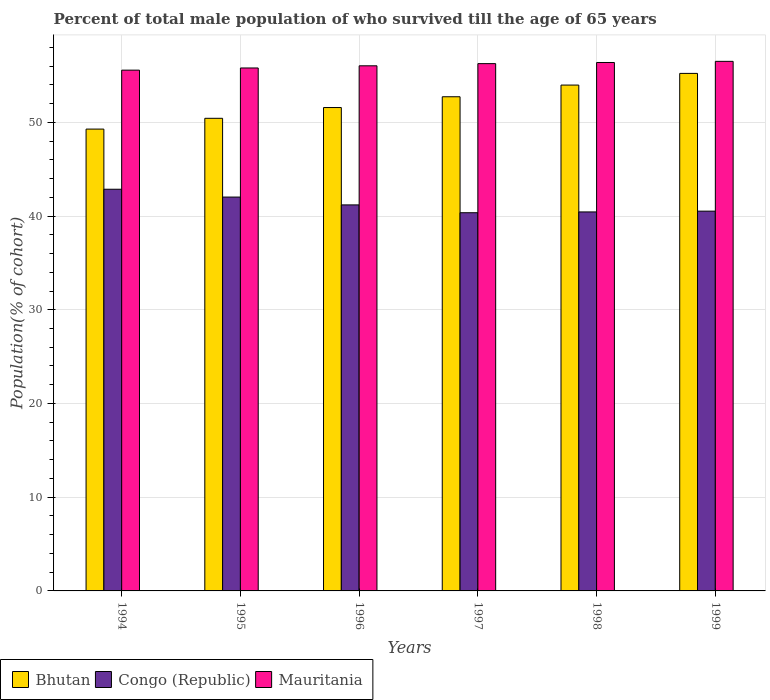How many different coloured bars are there?
Your answer should be very brief. 3. How many groups of bars are there?
Provide a succinct answer. 6. Are the number of bars per tick equal to the number of legend labels?
Provide a short and direct response. Yes. Are the number of bars on each tick of the X-axis equal?
Make the answer very short. Yes. What is the percentage of total male population who survived till the age of 65 years in Congo (Republic) in 1997?
Your response must be concise. 40.35. Across all years, what is the maximum percentage of total male population who survived till the age of 65 years in Bhutan?
Offer a very short reply. 55.22. Across all years, what is the minimum percentage of total male population who survived till the age of 65 years in Mauritania?
Your answer should be compact. 55.57. What is the total percentage of total male population who survived till the age of 65 years in Bhutan in the graph?
Make the answer very short. 313.19. What is the difference between the percentage of total male population who survived till the age of 65 years in Mauritania in 1996 and that in 1998?
Give a very brief answer. -0.35. What is the difference between the percentage of total male population who survived till the age of 65 years in Congo (Republic) in 1996 and the percentage of total male population who survived till the age of 65 years in Mauritania in 1995?
Offer a terse response. -14.61. What is the average percentage of total male population who survived till the age of 65 years in Congo (Republic) per year?
Offer a terse response. 41.23. In the year 1998, what is the difference between the percentage of total male population who survived till the age of 65 years in Mauritania and percentage of total male population who survived till the age of 65 years in Congo (Republic)?
Your response must be concise. 15.94. What is the ratio of the percentage of total male population who survived till the age of 65 years in Bhutan in 1996 to that in 1998?
Your answer should be compact. 0.96. What is the difference between the highest and the second highest percentage of total male population who survived till the age of 65 years in Bhutan?
Give a very brief answer. 1.25. What is the difference between the highest and the lowest percentage of total male population who survived till the age of 65 years in Bhutan?
Your response must be concise. 5.94. In how many years, is the percentage of total male population who survived till the age of 65 years in Bhutan greater than the average percentage of total male population who survived till the age of 65 years in Bhutan taken over all years?
Give a very brief answer. 3. Is the sum of the percentage of total male population who survived till the age of 65 years in Congo (Republic) in 1994 and 1997 greater than the maximum percentage of total male population who survived till the age of 65 years in Bhutan across all years?
Your answer should be very brief. Yes. What does the 2nd bar from the left in 1996 represents?
Make the answer very short. Congo (Republic). What does the 3rd bar from the right in 1995 represents?
Keep it short and to the point. Bhutan. What is the difference between two consecutive major ticks on the Y-axis?
Make the answer very short. 10. Does the graph contain any zero values?
Offer a terse response. No. How many legend labels are there?
Make the answer very short. 3. What is the title of the graph?
Your answer should be very brief. Percent of total male population of who survived till the age of 65 years. What is the label or title of the Y-axis?
Your answer should be very brief. Population(% of cohort). What is the Population(% of cohort) of Bhutan in 1994?
Offer a very short reply. 49.28. What is the Population(% of cohort) of Congo (Republic) in 1994?
Your answer should be compact. 42.86. What is the Population(% of cohort) of Mauritania in 1994?
Give a very brief answer. 55.57. What is the Population(% of cohort) of Bhutan in 1995?
Offer a terse response. 50.43. What is the Population(% of cohort) of Congo (Republic) in 1995?
Your answer should be very brief. 42.02. What is the Population(% of cohort) in Mauritania in 1995?
Provide a short and direct response. 55.8. What is the Population(% of cohort) of Bhutan in 1996?
Offer a very short reply. 51.58. What is the Population(% of cohort) of Congo (Republic) in 1996?
Offer a very short reply. 41.19. What is the Population(% of cohort) of Mauritania in 1996?
Offer a very short reply. 56.03. What is the Population(% of cohort) in Bhutan in 1997?
Offer a terse response. 52.73. What is the Population(% of cohort) in Congo (Republic) in 1997?
Your response must be concise. 40.35. What is the Population(% of cohort) of Mauritania in 1997?
Provide a short and direct response. 56.26. What is the Population(% of cohort) in Bhutan in 1998?
Offer a terse response. 53.97. What is the Population(% of cohort) of Congo (Republic) in 1998?
Offer a very short reply. 40.44. What is the Population(% of cohort) of Mauritania in 1998?
Your response must be concise. 56.38. What is the Population(% of cohort) in Bhutan in 1999?
Your answer should be compact. 55.22. What is the Population(% of cohort) in Congo (Republic) in 1999?
Ensure brevity in your answer.  40.52. What is the Population(% of cohort) of Mauritania in 1999?
Offer a very short reply. 56.5. Across all years, what is the maximum Population(% of cohort) of Bhutan?
Your answer should be very brief. 55.22. Across all years, what is the maximum Population(% of cohort) in Congo (Republic)?
Ensure brevity in your answer.  42.86. Across all years, what is the maximum Population(% of cohort) in Mauritania?
Provide a short and direct response. 56.5. Across all years, what is the minimum Population(% of cohort) of Bhutan?
Offer a very short reply. 49.28. Across all years, what is the minimum Population(% of cohort) in Congo (Republic)?
Keep it short and to the point. 40.35. Across all years, what is the minimum Population(% of cohort) of Mauritania?
Provide a short and direct response. 55.57. What is the total Population(% of cohort) of Bhutan in the graph?
Offer a terse response. 313.19. What is the total Population(% of cohort) of Congo (Republic) in the graph?
Make the answer very short. 247.38. What is the total Population(% of cohort) in Mauritania in the graph?
Your answer should be very brief. 336.53. What is the difference between the Population(% of cohort) in Bhutan in 1994 and that in 1995?
Your answer should be very brief. -1.15. What is the difference between the Population(% of cohort) in Congo (Republic) in 1994 and that in 1995?
Your answer should be compact. 0.84. What is the difference between the Population(% of cohort) in Mauritania in 1994 and that in 1995?
Keep it short and to the point. -0.23. What is the difference between the Population(% of cohort) in Bhutan in 1994 and that in 1996?
Make the answer very short. -2.3. What is the difference between the Population(% of cohort) of Congo (Republic) in 1994 and that in 1996?
Your response must be concise. 1.67. What is the difference between the Population(% of cohort) of Mauritania in 1994 and that in 1996?
Offer a terse response. -0.46. What is the difference between the Population(% of cohort) of Bhutan in 1994 and that in 1997?
Offer a very short reply. -3.45. What is the difference between the Population(% of cohort) in Congo (Republic) in 1994 and that in 1997?
Offer a very short reply. 2.51. What is the difference between the Population(% of cohort) of Mauritania in 1994 and that in 1997?
Your response must be concise. -0.69. What is the difference between the Population(% of cohort) of Bhutan in 1994 and that in 1998?
Give a very brief answer. -4.7. What is the difference between the Population(% of cohort) in Congo (Republic) in 1994 and that in 1998?
Provide a short and direct response. 2.42. What is the difference between the Population(% of cohort) of Mauritania in 1994 and that in 1998?
Provide a short and direct response. -0.82. What is the difference between the Population(% of cohort) of Bhutan in 1994 and that in 1999?
Provide a succinct answer. -5.94. What is the difference between the Population(% of cohort) of Congo (Republic) in 1994 and that in 1999?
Your answer should be very brief. 2.34. What is the difference between the Population(% of cohort) in Mauritania in 1994 and that in 1999?
Your answer should be compact. -0.94. What is the difference between the Population(% of cohort) in Bhutan in 1995 and that in 1996?
Provide a succinct answer. -1.15. What is the difference between the Population(% of cohort) of Congo (Republic) in 1995 and that in 1996?
Give a very brief answer. 0.84. What is the difference between the Population(% of cohort) of Mauritania in 1995 and that in 1996?
Give a very brief answer. -0.23. What is the difference between the Population(% of cohort) in Bhutan in 1995 and that in 1997?
Your answer should be very brief. -2.3. What is the difference between the Population(% of cohort) of Congo (Republic) in 1995 and that in 1997?
Your answer should be compact. 1.67. What is the difference between the Population(% of cohort) of Mauritania in 1995 and that in 1997?
Offer a very short reply. -0.46. What is the difference between the Population(% of cohort) of Bhutan in 1995 and that in 1998?
Offer a terse response. -3.55. What is the difference between the Population(% of cohort) of Congo (Republic) in 1995 and that in 1998?
Give a very brief answer. 1.59. What is the difference between the Population(% of cohort) in Mauritania in 1995 and that in 1998?
Provide a short and direct response. -0.58. What is the difference between the Population(% of cohort) in Bhutan in 1995 and that in 1999?
Provide a short and direct response. -4.79. What is the difference between the Population(% of cohort) of Congo (Republic) in 1995 and that in 1999?
Give a very brief answer. 1.5. What is the difference between the Population(% of cohort) of Mauritania in 1995 and that in 1999?
Provide a short and direct response. -0.71. What is the difference between the Population(% of cohort) in Bhutan in 1996 and that in 1997?
Provide a short and direct response. -1.15. What is the difference between the Population(% of cohort) of Congo (Republic) in 1996 and that in 1997?
Your answer should be compact. 0.84. What is the difference between the Population(% of cohort) in Mauritania in 1996 and that in 1997?
Provide a succinct answer. -0.23. What is the difference between the Population(% of cohort) of Bhutan in 1996 and that in 1998?
Keep it short and to the point. -2.4. What is the difference between the Population(% of cohort) in Congo (Republic) in 1996 and that in 1998?
Make the answer very short. 0.75. What is the difference between the Population(% of cohort) in Mauritania in 1996 and that in 1998?
Ensure brevity in your answer.  -0.35. What is the difference between the Population(% of cohort) of Bhutan in 1996 and that in 1999?
Offer a very short reply. -3.64. What is the difference between the Population(% of cohort) in Congo (Republic) in 1996 and that in 1999?
Ensure brevity in your answer.  0.67. What is the difference between the Population(% of cohort) in Mauritania in 1996 and that in 1999?
Your response must be concise. -0.47. What is the difference between the Population(% of cohort) in Bhutan in 1997 and that in 1998?
Your answer should be compact. -1.25. What is the difference between the Population(% of cohort) in Congo (Republic) in 1997 and that in 1998?
Keep it short and to the point. -0.08. What is the difference between the Population(% of cohort) of Mauritania in 1997 and that in 1998?
Offer a very short reply. -0.12. What is the difference between the Population(% of cohort) of Bhutan in 1997 and that in 1999?
Your answer should be very brief. -2.49. What is the difference between the Population(% of cohort) in Congo (Republic) in 1997 and that in 1999?
Make the answer very short. -0.17. What is the difference between the Population(% of cohort) of Mauritania in 1997 and that in 1999?
Offer a very short reply. -0.24. What is the difference between the Population(% of cohort) of Bhutan in 1998 and that in 1999?
Your response must be concise. -1.25. What is the difference between the Population(% of cohort) in Congo (Republic) in 1998 and that in 1999?
Offer a very short reply. -0.08. What is the difference between the Population(% of cohort) of Mauritania in 1998 and that in 1999?
Offer a very short reply. -0.12. What is the difference between the Population(% of cohort) in Bhutan in 1994 and the Population(% of cohort) in Congo (Republic) in 1995?
Provide a succinct answer. 7.25. What is the difference between the Population(% of cohort) of Bhutan in 1994 and the Population(% of cohort) of Mauritania in 1995?
Ensure brevity in your answer.  -6.52. What is the difference between the Population(% of cohort) in Congo (Republic) in 1994 and the Population(% of cohort) in Mauritania in 1995?
Keep it short and to the point. -12.94. What is the difference between the Population(% of cohort) of Bhutan in 1994 and the Population(% of cohort) of Congo (Republic) in 1996?
Keep it short and to the point. 8.09. What is the difference between the Population(% of cohort) in Bhutan in 1994 and the Population(% of cohort) in Mauritania in 1996?
Provide a short and direct response. -6.75. What is the difference between the Population(% of cohort) of Congo (Republic) in 1994 and the Population(% of cohort) of Mauritania in 1996?
Your answer should be very brief. -13.17. What is the difference between the Population(% of cohort) of Bhutan in 1994 and the Population(% of cohort) of Congo (Republic) in 1997?
Provide a succinct answer. 8.92. What is the difference between the Population(% of cohort) in Bhutan in 1994 and the Population(% of cohort) in Mauritania in 1997?
Offer a terse response. -6.98. What is the difference between the Population(% of cohort) of Congo (Republic) in 1994 and the Population(% of cohort) of Mauritania in 1997?
Make the answer very short. -13.4. What is the difference between the Population(% of cohort) of Bhutan in 1994 and the Population(% of cohort) of Congo (Republic) in 1998?
Ensure brevity in your answer.  8.84. What is the difference between the Population(% of cohort) of Bhutan in 1994 and the Population(% of cohort) of Mauritania in 1998?
Make the answer very short. -7.1. What is the difference between the Population(% of cohort) in Congo (Republic) in 1994 and the Population(% of cohort) in Mauritania in 1998?
Your answer should be very brief. -13.52. What is the difference between the Population(% of cohort) in Bhutan in 1994 and the Population(% of cohort) in Congo (Republic) in 1999?
Your answer should be compact. 8.76. What is the difference between the Population(% of cohort) in Bhutan in 1994 and the Population(% of cohort) in Mauritania in 1999?
Your answer should be very brief. -7.23. What is the difference between the Population(% of cohort) of Congo (Republic) in 1994 and the Population(% of cohort) of Mauritania in 1999?
Your response must be concise. -13.65. What is the difference between the Population(% of cohort) in Bhutan in 1995 and the Population(% of cohort) in Congo (Republic) in 1996?
Offer a very short reply. 9.24. What is the difference between the Population(% of cohort) of Bhutan in 1995 and the Population(% of cohort) of Mauritania in 1996?
Give a very brief answer. -5.6. What is the difference between the Population(% of cohort) in Congo (Republic) in 1995 and the Population(% of cohort) in Mauritania in 1996?
Provide a succinct answer. -14.01. What is the difference between the Population(% of cohort) of Bhutan in 1995 and the Population(% of cohort) of Congo (Republic) in 1997?
Offer a very short reply. 10.07. What is the difference between the Population(% of cohort) in Bhutan in 1995 and the Population(% of cohort) in Mauritania in 1997?
Ensure brevity in your answer.  -5.83. What is the difference between the Population(% of cohort) of Congo (Republic) in 1995 and the Population(% of cohort) of Mauritania in 1997?
Ensure brevity in your answer.  -14.24. What is the difference between the Population(% of cohort) of Bhutan in 1995 and the Population(% of cohort) of Congo (Republic) in 1998?
Provide a short and direct response. 9.99. What is the difference between the Population(% of cohort) of Bhutan in 1995 and the Population(% of cohort) of Mauritania in 1998?
Offer a terse response. -5.96. What is the difference between the Population(% of cohort) in Congo (Republic) in 1995 and the Population(% of cohort) in Mauritania in 1998?
Your answer should be compact. -14.36. What is the difference between the Population(% of cohort) in Bhutan in 1995 and the Population(% of cohort) in Congo (Republic) in 1999?
Provide a short and direct response. 9.9. What is the difference between the Population(% of cohort) of Bhutan in 1995 and the Population(% of cohort) of Mauritania in 1999?
Your answer should be very brief. -6.08. What is the difference between the Population(% of cohort) of Congo (Republic) in 1995 and the Population(% of cohort) of Mauritania in 1999?
Your answer should be compact. -14.48. What is the difference between the Population(% of cohort) of Bhutan in 1996 and the Population(% of cohort) of Congo (Republic) in 1997?
Offer a very short reply. 11.22. What is the difference between the Population(% of cohort) in Bhutan in 1996 and the Population(% of cohort) in Mauritania in 1997?
Offer a terse response. -4.68. What is the difference between the Population(% of cohort) of Congo (Republic) in 1996 and the Population(% of cohort) of Mauritania in 1997?
Offer a terse response. -15.07. What is the difference between the Population(% of cohort) of Bhutan in 1996 and the Population(% of cohort) of Congo (Republic) in 1998?
Provide a short and direct response. 11.14. What is the difference between the Population(% of cohort) of Bhutan in 1996 and the Population(% of cohort) of Mauritania in 1998?
Give a very brief answer. -4.81. What is the difference between the Population(% of cohort) of Congo (Republic) in 1996 and the Population(% of cohort) of Mauritania in 1998?
Ensure brevity in your answer.  -15.19. What is the difference between the Population(% of cohort) of Bhutan in 1996 and the Population(% of cohort) of Congo (Republic) in 1999?
Keep it short and to the point. 11.05. What is the difference between the Population(% of cohort) in Bhutan in 1996 and the Population(% of cohort) in Mauritania in 1999?
Provide a succinct answer. -4.93. What is the difference between the Population(% of cohort) in Congo (Republic) in 1996 and the Population(% of cohort) in Mauritania in 1999?
Ensure brevity in your answer.  -15.32. What is the difference between the Population(% of cohort) of Bhutan in 1997 and the Population(% of cohort) of Congo (Republic) in 1998?
Offer a terse response. 12.29. What is the difference between the Population(% of cohort) of Bhutan in 1997 and the Population(% of cohort) of Mauritania in 1998?
Offer a terse response. -3.66. What is the difference between the Population(% of cohort) of Congo (Republic) in 1997 and the Population(% of cohort) of Mauritania in 1998?
Give a very brief answer. -16.03. What is the difference between the Population(% of cohort) in Bhutan in 1997 and the Population(% of cohort) in Congo (Republic) in 1999?
Give a very brief answer. 12.2. What is the difference between the Population(% of cohort) of Bhutan in 1997 and the Population(% of cohort) of Mauritania in 1999?
Offer a very short reply. -3.78. What is the difference between the Population(% of cohort) in Congo (Republic) in 1997 and the Population(% of cohort) in Mauritania in 1999?
Offer a terse response. -16.15. What is the difference between the Population(% of cohort) in Bhutan in 1998 and the Population(% of cohort) in Congo (Republic) in 1999?
Your answer should be compact. 13.45. What is the difference between the Population(% of cohort) in Bhutan in 1998 and the Population(% of cohort) in Mauritania in 1999?
Ensure brevity in your answer.  -2.53. What is the difference between the Population(% of cohort) of Congo (Republic) in 1998 and the Population(% of cohort) of Mauritania in 1999?
Keep it short and to the point. -16.07. What is the average Population(% of cohort) in Bhutan per year?
Your answer should be compact. 52.2. What is the average Population(% of cohort) of Congo (Republic) per year?
Your answer should be compact. 41.23. What is the average Population(% of cohort) of Mauritania per year?
Provide a short and direct response. 56.09. In the year 1994, what is the difference between the Population(% of cohort) in Bhutan and Population(% of cohort) in Congo (Republic)?
Keep it short and to the point. 6.42. In the year 1994, what is the difference between the Population(% of cohort) in Bhutan and Population(% of cohort) in Mauritania?
Make the answer very short. -6.29. In the year 1994, what is the difference between the Population(% of cohort) of Congo (Republic) and Population(% of cohort) of Mauritania?
Offer a terse response. -12.71. In the year 1995, what is the difference between the Population(% of cohort) in Bhutan and Population(% of cohort) in Congo (Republic)?
Offer a terse response. 8.4. In the year 1995, what is the difference between the Population(% of cohort) in Bhutan and Population(% of cohort) in Mauritania?
Provide a short and direct response. -5.37. In the year 1995, what is the difference between the Population(% of cohort) of Congo (Republic) and Population(% of cohort) of Mauritania?
Provide a succinct answer. -13.77. In the year 1996, what is the difference between the Population(% of cohort) in Bhutan and Population(% of cohort) in Congo (Republic)?
Provide a short and direct response. 10.39. In the year 1996, what is the difference between the Population(% of cohort) in Bhutan and Population(% of cohort) in Mauritania?
Make the answer very short. -4.45. In the year 1996, what is the difference between the Population(% of cohort) in Congo (Republic) and Population(% of cohort) in Mauritania?
Offer a very short reply. -14.84. In the year 1997, what is the difference between the Population(% of cohort) in Bhutan and Population(% of cohort) in Congo (Republic)?
Provide a short and direct response. 12.37. In the year 1997, what is the difference between the Population(% of cohort) of Bhutan and Population(% of cohort) of Mauritania?
Your response must be concise. -3.53. In the year 1997, what is the difference between the Population(% of cohort) of Congo (Republic) and Population(% of cohort) of Mauritania?
Keep it short and to the point. -15.91. In the year 1998, what is the difference between the Population(% of cohort) in Bhutan and Population(% of cohort) in Congo (Republic)?
Your answer should be very brief. 13.54. In the year 1998, what is the difference between the Population(% of cohort) of Bhutan and Population(% of cohort) of Mauritania?
Offer a terse response. -2.41. In the year 1998, what is the difference between the Population(% of cohort) of Congo (Republic) and Population(% of cohort) of Mauritania?
Give a very brief answer. -15.94. In the year 1999, what is the difference between the Population(% of cohort) of Bhutan and Population(% of cohort) of Congo (Republic)?
Your answer should be compact. 14.7. In the year 1999, what is the difference between the Population(% of cohort) of Bhutan and Population(% of cohort) of Mauritania?
Your answer should be very brief. -1.28. In the year 1999, what is the difference between the Population(% of cohort) of Congo (Republic) and Population(% of cohort) of Mauritania?
Offer a very short reply. -15.98. What is the ratio of the Population(% of cohort) of Bhutan in 1994 to that in 1995?
Provide a short and direct response. 0.98. What is the ratio of the Population(% of cohort) in Congo (Republic) in 1994 to that in 1995?
Ensure brevity in your answer.  1.02. What is the ratio of the Population(% of cohort) of Mauritania in 1994 to that in 1995?
Give a very brief answer. 1. What is the ratio of the Population(% of cohort) in Bhutan in 1994 to that in 1996?
Offer a terse response. 0.96. What is the ratio of the Population(% of cohort) in Congo (Republic) in 1994 to that in 1996?
Your answer should be very brief. 1.04. What is the ratio of the Population(% of cohort) of Bhutan in 1994 to that in 1997?
Ensure brevity in your answer.  0.93. What is the ratio of the Population(% of cohort) of Congo (Republic) in 1994 to that in 1997?
Make the answer very short. 1.06. What is the ratio of the Population(% of cohort) of Mauritania in 1994 to that in 1997?
Offer a very short reply. 0.99. What is the ratio of the Population(% of cohort) of Congo (Republic) in 1994 to that in 1998?
Give a very brief answer. 1.06. What is the ratio of the Population(% of cohort) in Mauritania in 1994 to that in 1998?
Provide a short and direct response. 0.99. What is the ratio of the Population(% of cohort) of Bhutan in 1994 to that in 1999?
Make the answer very short. 0.89. What is the ratio of the Population(% of cohort) of Congo (Republic) in 1994 to that in 1999?
Provide a short and direct response. 1.06. What is the ratio of the Population(% of cohort) in Mauritania in 1994 to that in 1999?
Your answer should be compact. 0.98. What is the ratio of the Population(% of cohort) of Bhutan in 1995 to that in 1996?
Offer a very short reply. 0.98. What is the ratio of the Population(% of cohort) in Congo (Republic) in 1995 to that in 1996?
Keep it short and to the point. 1.02. What is the ratio of the Population(% of cohort) of Bhutan in 1995 to that in 1997?
Keep it short and to the point. 0.96. What is the ratio of the Population(% of cohort) in Congo (Republic) in 1995 to that in 1997?
Your answer should be very brief. 1.04. What is the ratio of the Population(% of cohort) in Bhutan in 1995 to that in 1998?
Provide a short and direct response. 0.93. What is the ratio of the Population(% of cohort) of Congo (Republic) in 1995 to that in 1998?
Your answer should be very brief. 1.04. What is the ratio of the Population(% of cohort) of Bhutan in 1995 to that in 1999?
Provide a short and direct response. 0.91. What is the ratio of the Population(% of cohort) of Congo (Republic) in 1995 to that in 1999?
Your response must be concise. 1.04. What is the ratio of the Population(% of cohort) in Mauritania in 1995 to that in 1999?
Keep it short and to the point. 0.99. What is the ratio of the Population(% of cohort) of Bhutan in 1996 to that in 1997?
Your response must be concise. 0.98. What is the ratio of the Population(% of cohort) of Congo (Republic) in 1996 to that in 1997?
Your response must be concise. 1.02. What is the ratio of the Population(% of cohort) in Bhutan in 1996 to that in 1998?
Give a very brief answer. 0.96. What is the ratio of the Population(% of cohort) in Congo (Republic) in 1996 to that in 1998?
Your answer should be compact. 1.02. What is the ratio of the Population(% of cohort) of Mauritania in 1996 to that in 1998?
Make the answer very short. 0.99. What is the ratio of the Population(% of cohort) in Bhutan in 1996 to that in 1999?
Offer a terse response. 0.93. What is the ratio of the Population(% of cohort) in Congo (Republic) in 1996 to that in 1999?
Give a very brief answer. 1.02. What is the ratio of the Population(% of cohort) of Bhutan in 1997 to that in 1998?
Provide a succinct answer. 0.98. What is the ratio of the Population(% of cohort) in Mauritania in 1997 to that in 1998?
Make the answer very short. 1. What is the ratio of the Population(% of cohort) in Bhutan in 1997 to that in 1999?
Give a very brief answer. 0.95. What is the ratio of the Population(% of cohort) in Congo (Republic) in 1997 to that in 1999?
Your answer should be very brief. 1. What is the ratio of the Population(% of cohort) of Mauritania in 1997 to that in 1999?
Give a very brief answer. 1. What is the ratio of the Population(% of cohort) in Bhutan in 1998 to that in 1999?
Give a very brief answer. 0.98. What is the ratio of the Population(% of cohort) of Mauritania in 1998 to that in 1999?
Keep it short and to the point. 1. What is the difference between the highest and the second highest Population(% of cohort) in Bhutan?
Your answer should be compact. 1.25. What is the difference between the highest and the second highest Population(% of cohort) in Congo (Republic)?
Your response must be concise. 0.84. What is the difference between the highest and the second highest Population(% of cohort) of Mauritania?
Your answer should be compact. 0.12. What is the difference between the highest and the lowest Population(% of cohort) in Bhutan?
Provide a short and direct response. 5.94. What is the difference between the highest and the lowest Population(% of cohort) of Congo (Republic)?
Make the answer very short. 2.51. What is the difference between the highest and the lowest Population(% of cohort) in Mauritania?
Offer a very short reply. 0.94. 